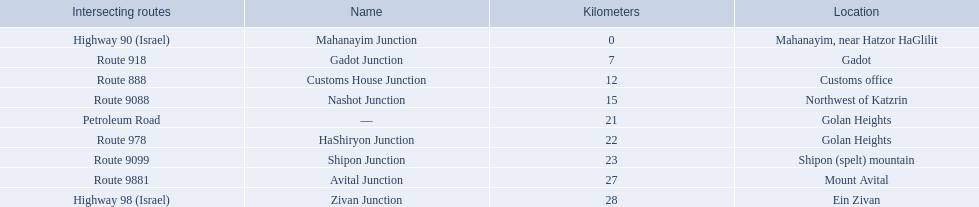Which junctions cross a route? Gadot Junction, Customs House Junction, Nashot Junction, HaShiryon Junction, Shipon Junction, Avital Junction. Which of these shares [art of its name with its locations name? Gadot Junction, Customs House Junction, Shipon Junction, Avital Junction. Which of them is not located in a locations named after a mountain? Gadot Junction, Customs House Junction. Which of these has the highest route number? Gadot Junction. 